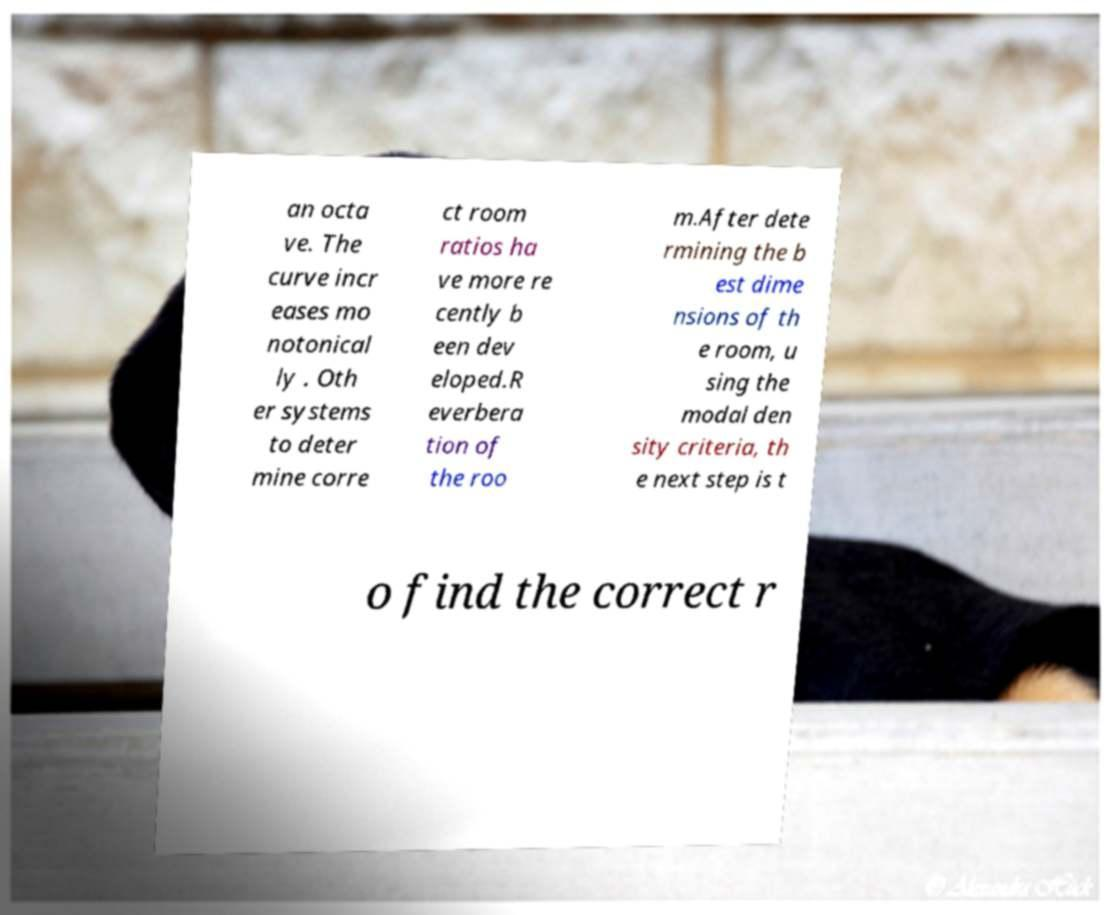Please read and relay the text visible in this image. What does it say? an octa ve. The curve incr eases mo notonical ly . Oth er systems to deter mine corre ct room ratios ha ve more re cently b een dev eloped.R everbera tion of the roo m.After dete rmining the b est dime nsions of th e room, u sing the modal den sity criteria, th e next step is t o find the correct r 